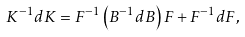Convert formula to latex. <formula><loc_0><loc_0><loc_500><loc_500>K ^ { - 1 } d K = F ^ { - 1 } \left ( B ^ { - 1 } d B \right ) F + F ^ { - 1 } d F ,</formula> 